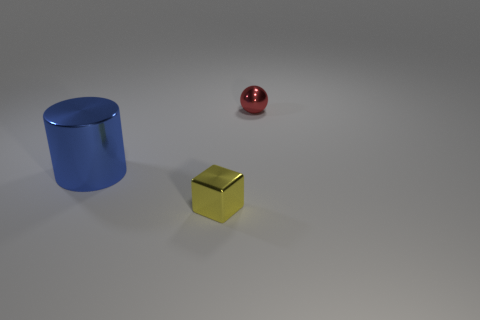Is there anything else that has the same size as the metallic cylinder?
Your answer should be compact. No. Is there another shiny cube that has the same color as the metallic cube?
Ensure brevity in your answer.  No. What shape is the thing that is the same size as the red ball?
Keep it short and to the point. Cube. There is a tiny sphere that is behind the blue cylinder; what number of small red balls are on the left side of it?
Offer a very short reply. 0. Is the tiny shiny block the same color as the large cylinder?
Offer a terse response. No. What number of other objects are the same material as the large thing?
Offer a terse response. 2. There is a tiny object that is on the right side of the small yellow cube that is in front of the big blue thing; what shape is it?
Offer a very short reply. Sphere. There is a thing that is in front of the big blue shiny object; how big is it?
Make the answer very short. Small. Do the large object and the small yellow thing have the same material?
Ensure brevity in your answer.  Yes. There is a red thing that is the same material as the tiny yellow object; what is its shape?
Keep it short and to the point. Sphere. 